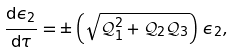<formula> <loc_0><loc_0><loc_500><loc_500>\frac { { \mathrm d } \epsilon _ { 2 } } { { \mathrm d } \tau } = \pm \left ( \sqrt { { \mathcal { Q } } _ { 1 } ^ { 2 } + { \mathcal { Q } } _ { 2 } { \mathcal { Q } } _ { 3 } } \right ) \, \epsilon _ { 2 } ,</formula> 